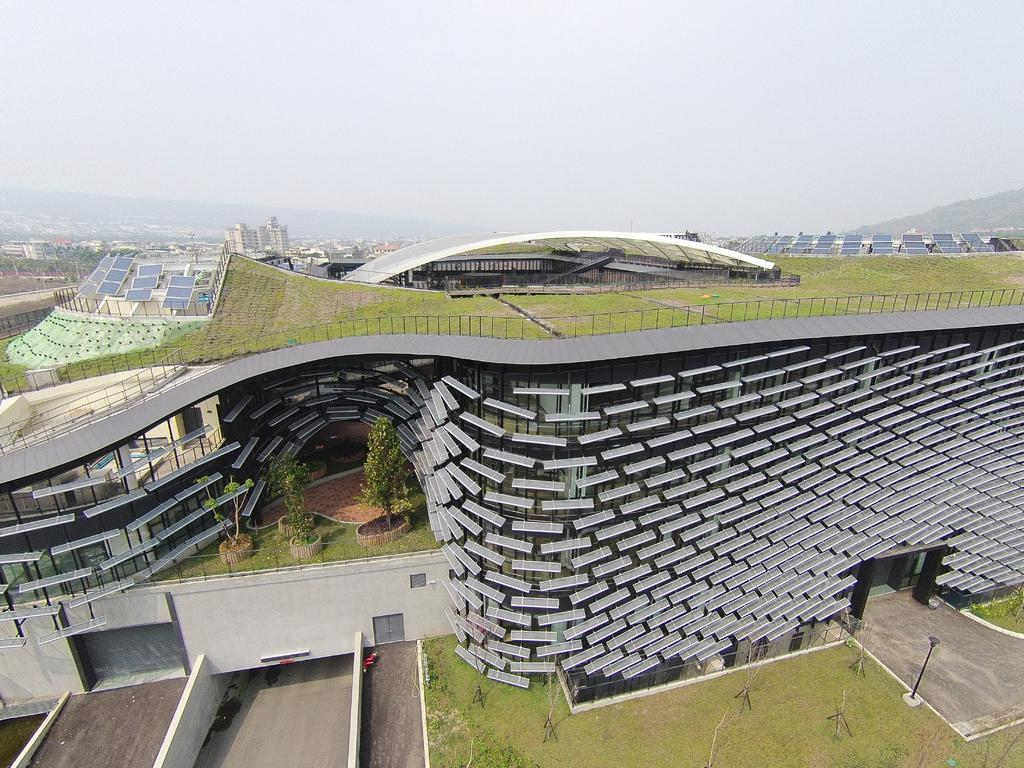What type of structures are present in the image? There are buildings with solar lights in the image. What type of vegetation can be seen in the image? There are trees in the image. What type of ground cover is present in the image? There is grass in the image. What is visible beneath the structures and vegetation? There is ground visible in the image. What other object can be seen in the image? There is a pole in the image. What is visible at the top of the image? The sky is visible at the top of the image. What type of kettle is being used to draw the buildings in the image? There is no kettle present in the image. 